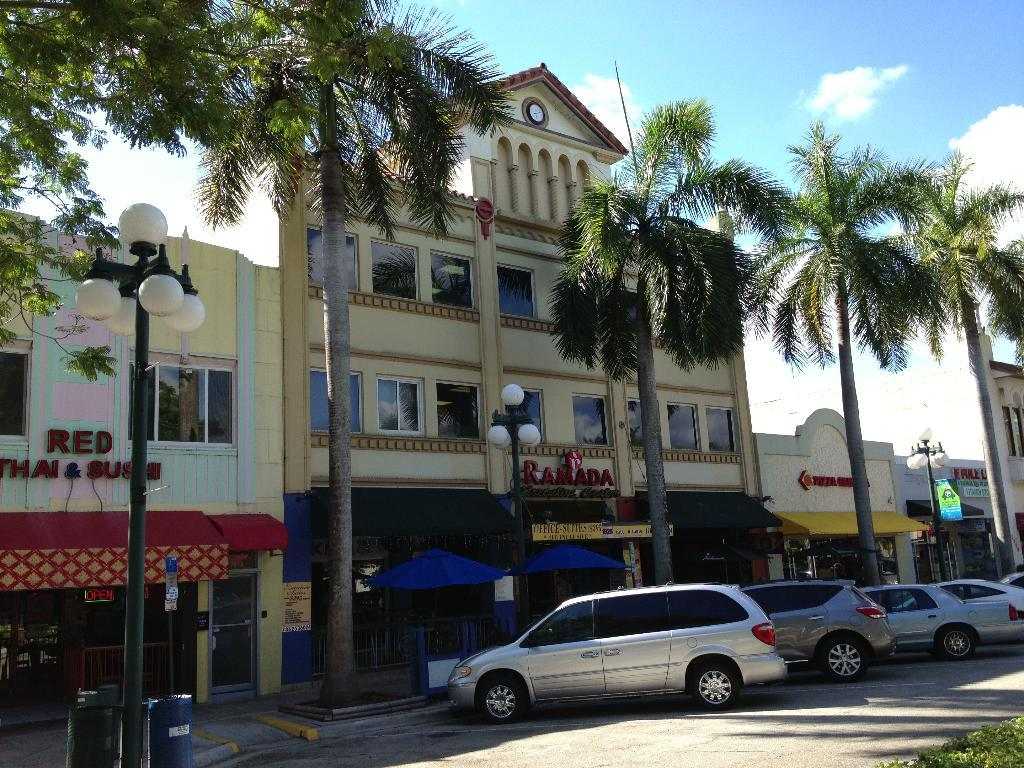What type of structures can be seen in the image? There are buildings in the image. What natural elements are present in the image? There are trees in the image. What type of lighting is visible in the image? There are pole lights in the image. What type of vehicles can be seen in the image? Cars are parked on the side in the image. Can you see any pigs or owls in the image? No, there are no pigs or owls present in the image. Is anyone wearing a scarf in the image? There is no information about people or clothing in the image, so it cannot be determined if anyone is wearing a scarf. 